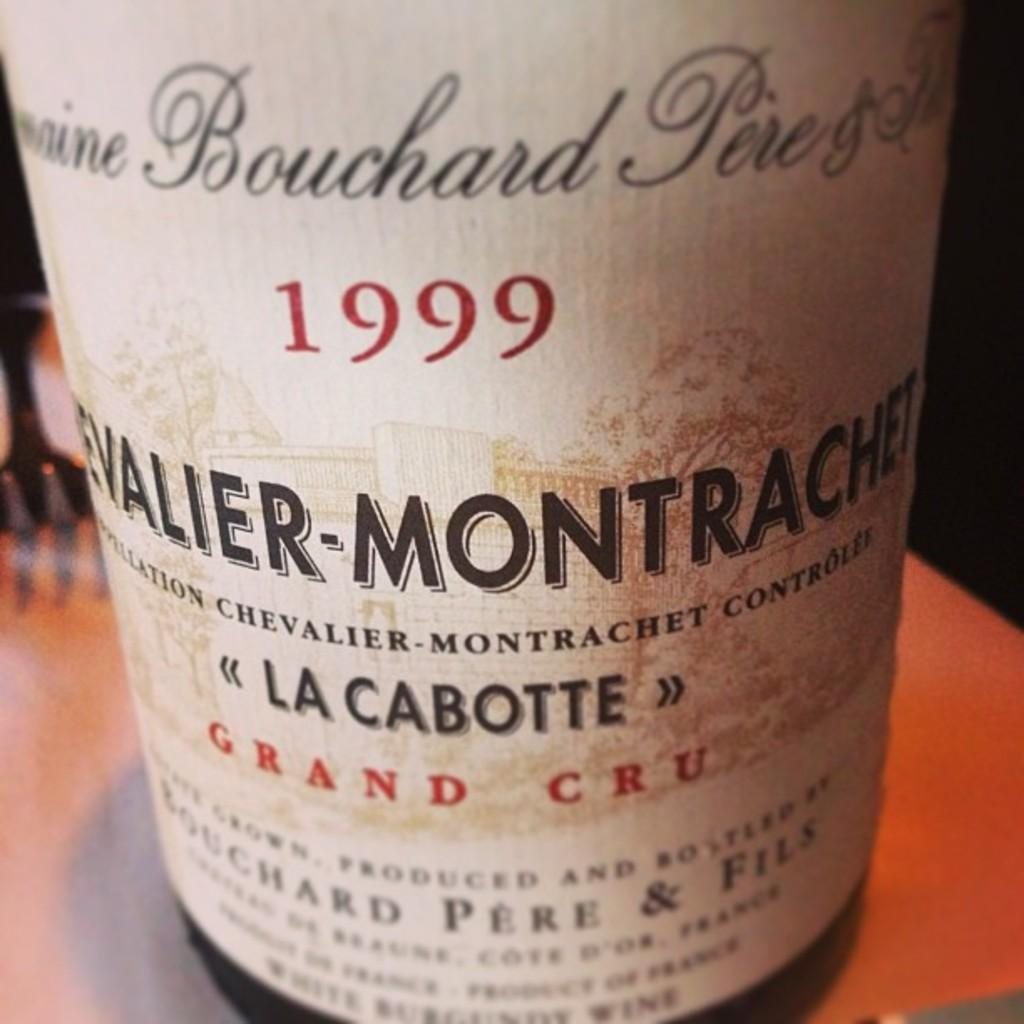Provide a one-sentence caption for the provided image. A bottle of wine from 1999 from La Cabotte. 